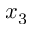Convert formula to latex. <formula><loc_0><loc_0><loc_500><loc_500>x _ { 3 }</formula> 